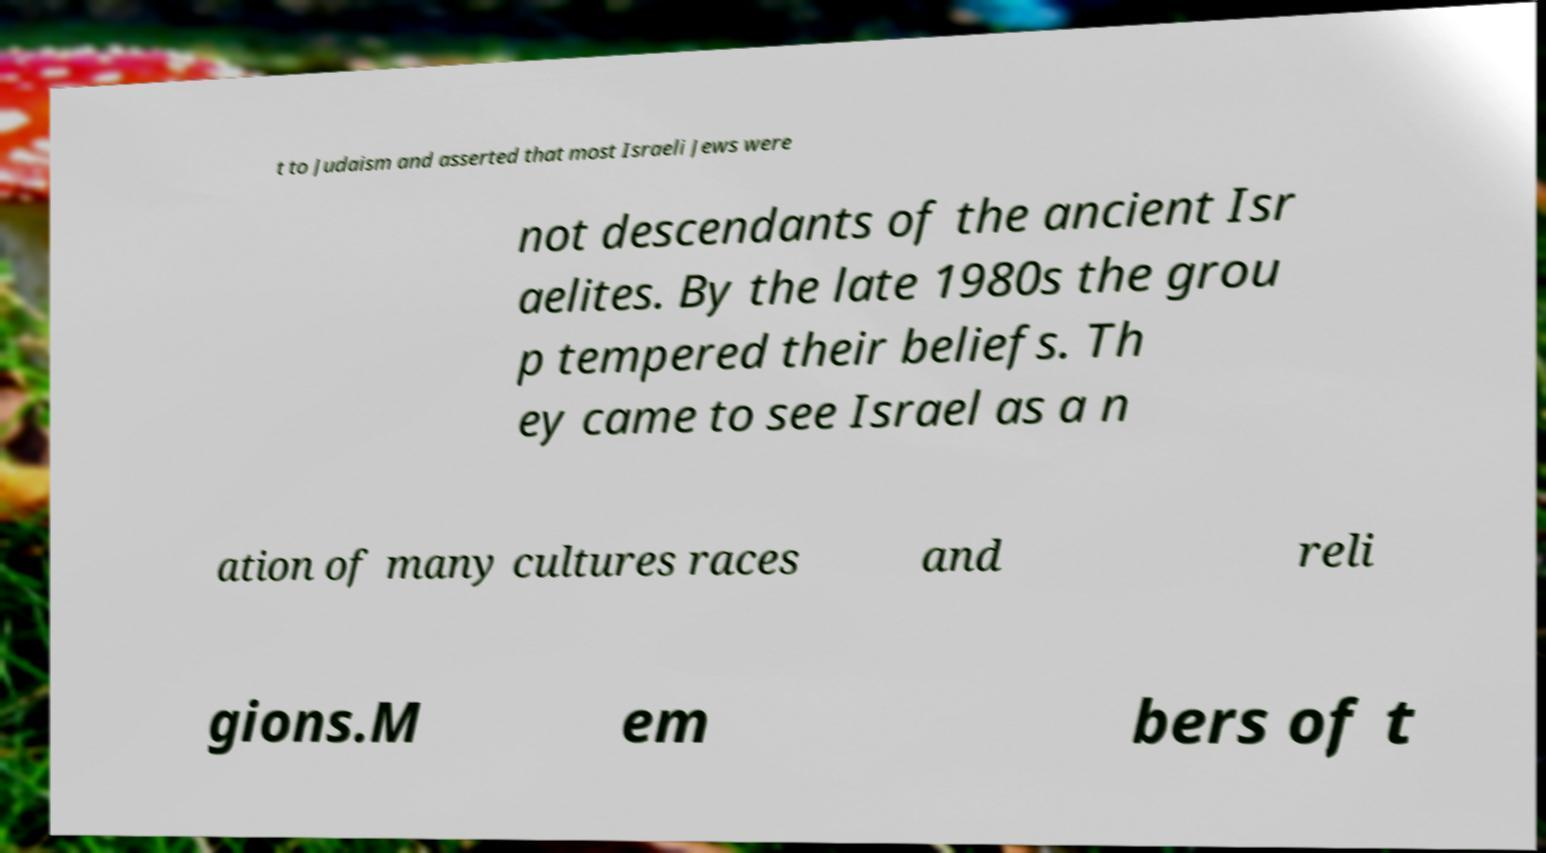What messages or text are displayed in this image? I need them in a readable, typed format. t to Judaism and asserted that most Israeli Jews were not descendants of the ancient Isr aelites. By the late 1980s the grou p tempered their beliefs. Th ey came to see Israel as a n ation of many cultures races and reli gions.M em bers of t 